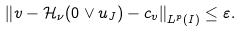Convert formula to latex. <formula><loc_0><loc_0><loc_500><loc_500>\left \| v - { \mathcal { H } } _ { \nu } ( 0 \vee u _ { J } ) - c _ { v } \right \| _ { L ^ { p } ( I ) } \leq \varepsilon .</formula> 